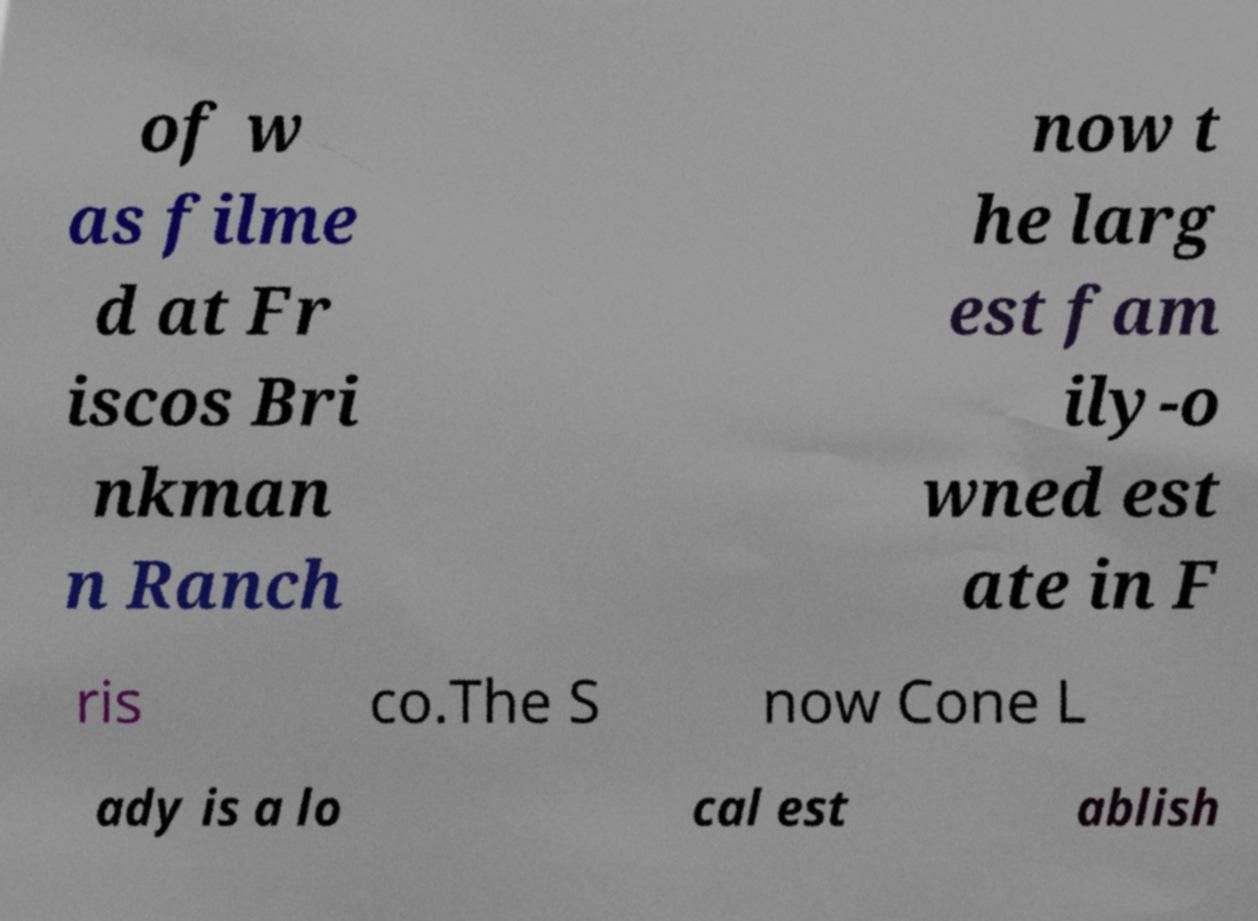Could you assist in decoding the text presented in this image and type it out clearly? of w as filme d at Fr iscos Bri nkman n Ranch now t he larg est fam ily-o wned est ate in F ris co.The S now Cone L ady is a lo cal est ablish 